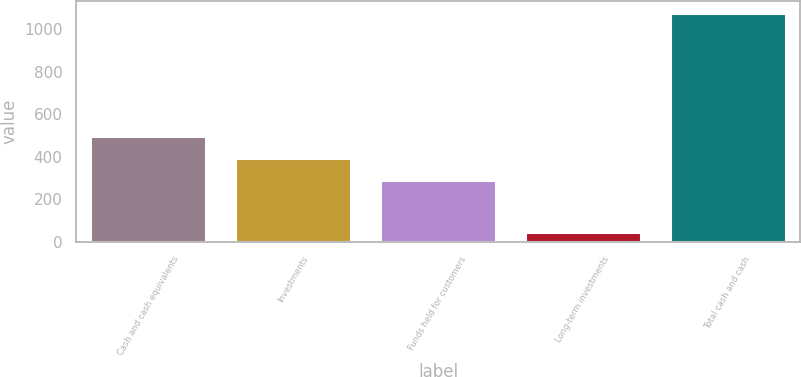Convert chart. <chart><loc_0><loc_0><loc_500><loc_500><bar_chart><fcel>Cash and cash equivalents<fcel>Investments<fcel>Funds held for customers<fcel>Long-term investments<fcel>Total cash and cash<nl><fcel>495.4<fcel>392.2<fcel>289<fcel>47<fcel>1079<nl></chart> 